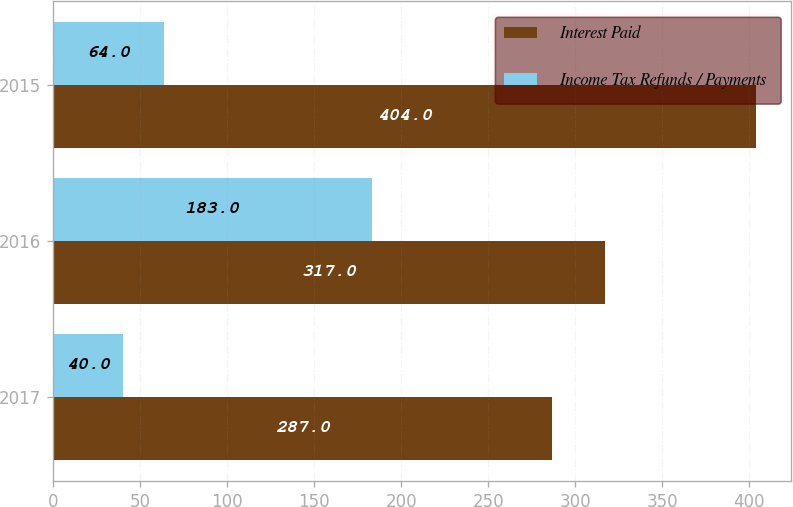<chart> <loc_0><loc_0><loc_500><loc_500><stacked_bar_chart><ecel><fcel>2017<fcel>2016<fcel>2015<nl><fcel>Interest Paid<fcel>287<fcel>317<fcel>404<nl><fcel>Income Tax Refunds / Payments<fcel>40<fcel>183<fcel>64<nl></chart> 